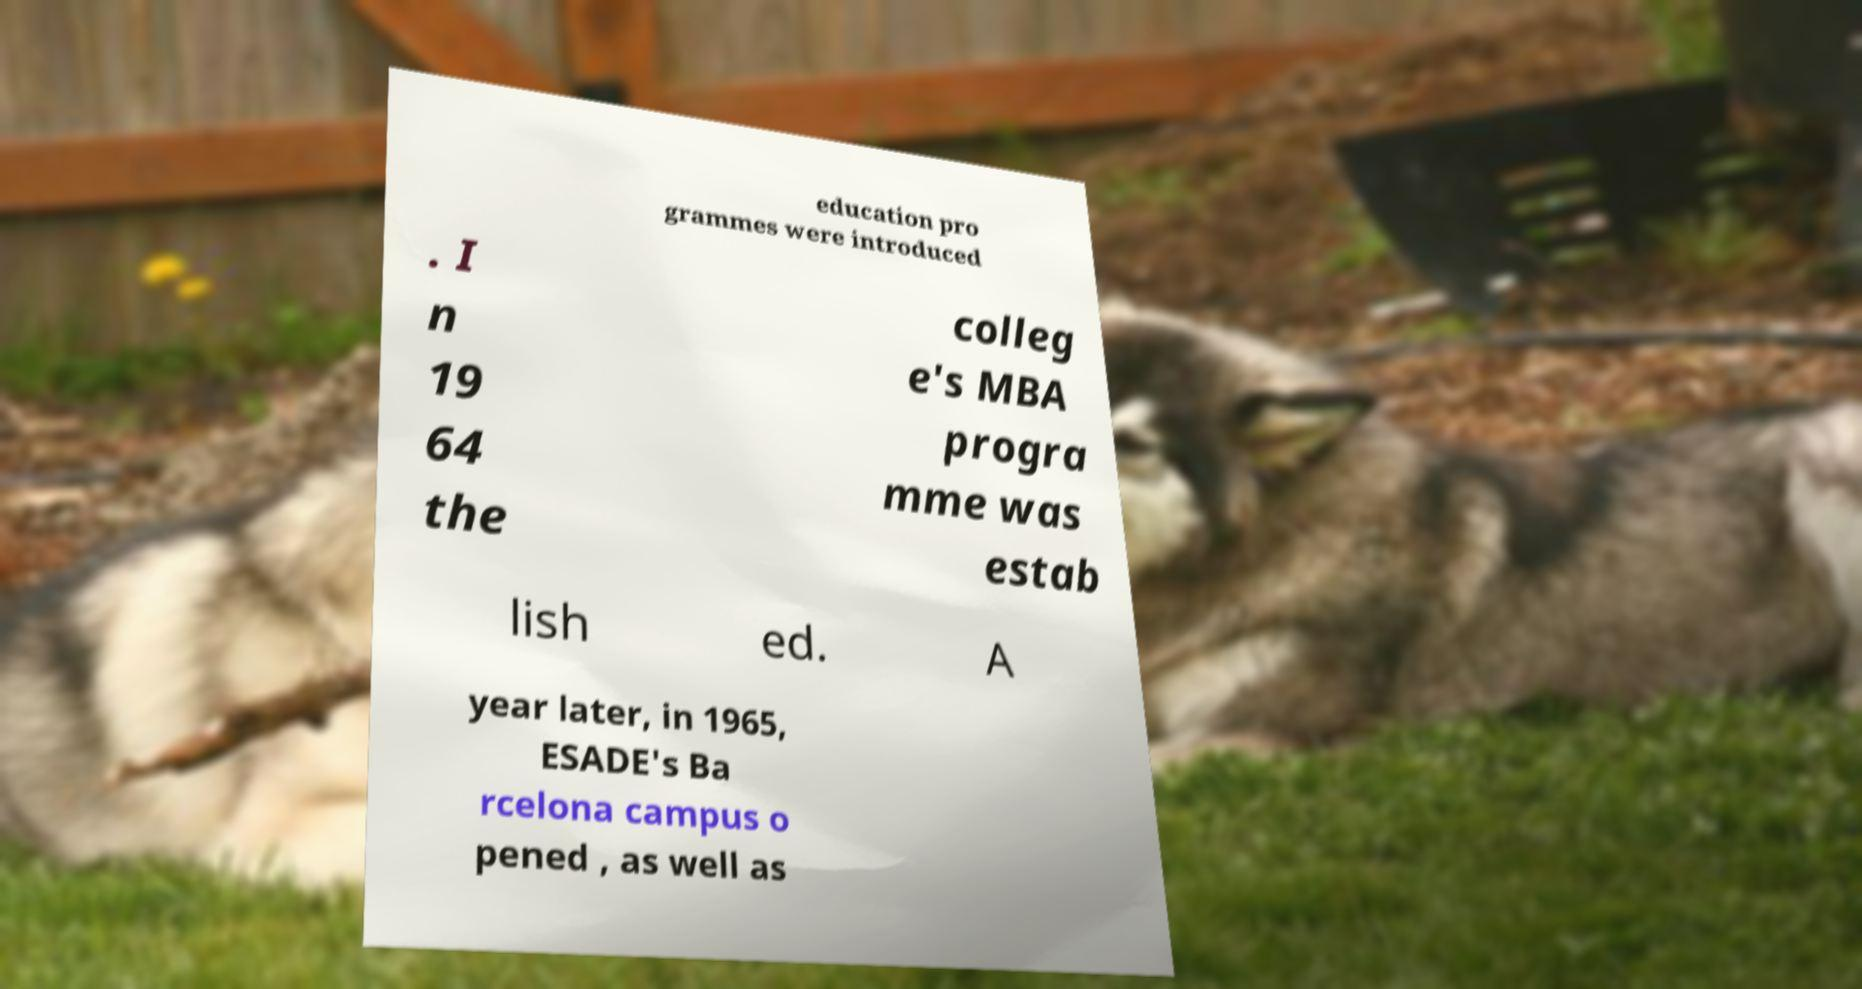Could you extract and type out the text from this image? education pro grammes were introduced . I n 19 64 the colleg e's MBA progra mme was estab lish ed. A year later, in 1965, ESADE's Ba rcelona campus o pened , as well as 